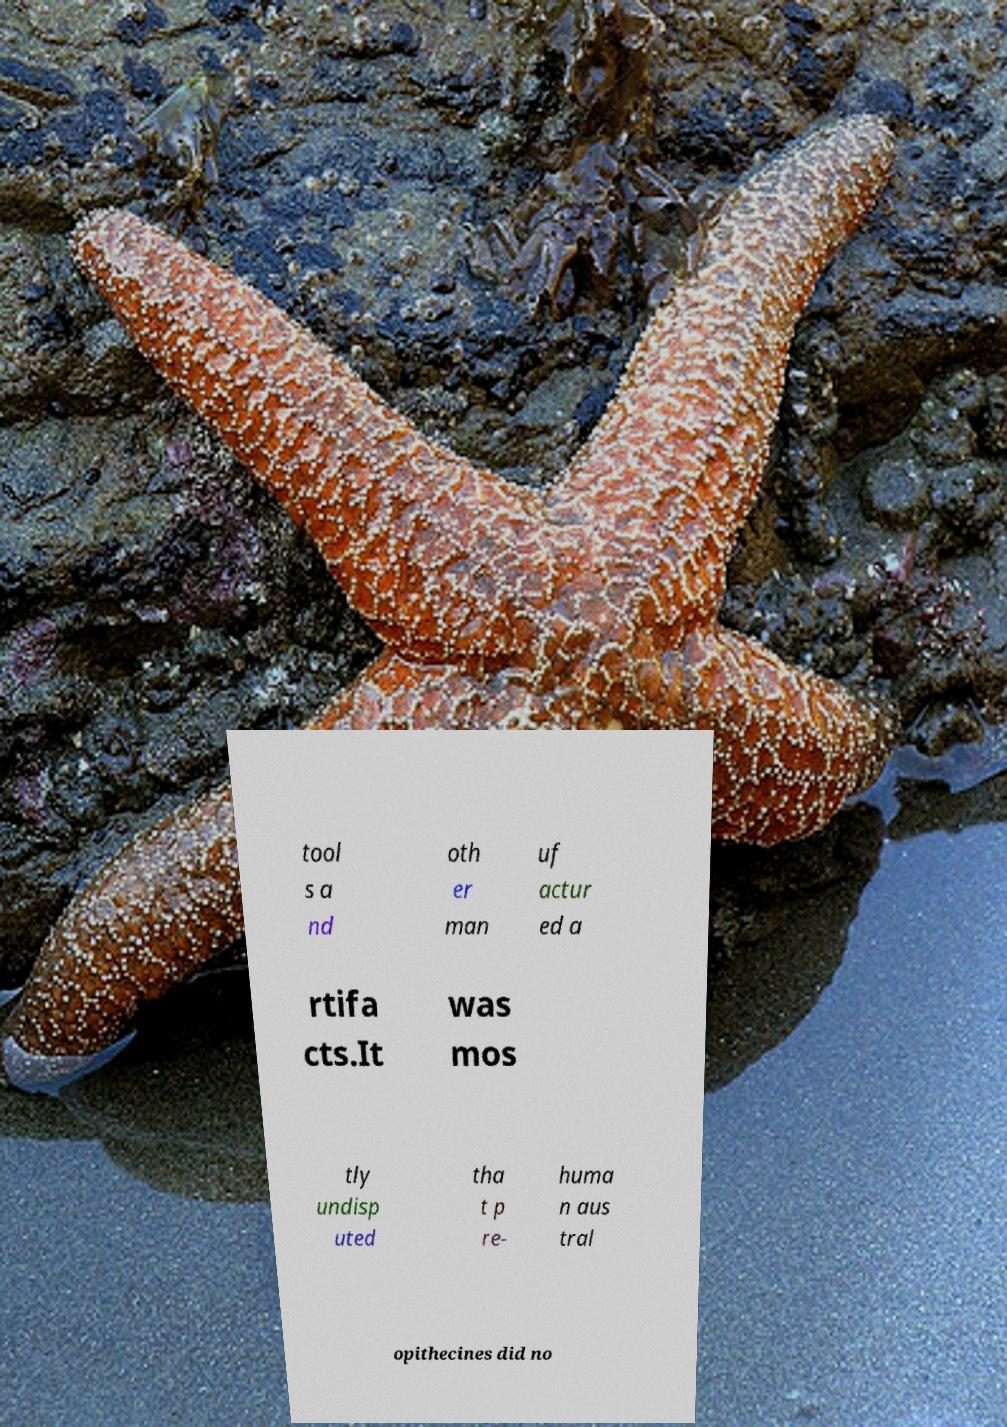Could you assist in decoding the text presented in this image and type it out clearly? tool s a nd oth er man uf actur ed a rtifa cts.It was mos tly undisp uted tha t p re- huma n aus tral opithecines did no 